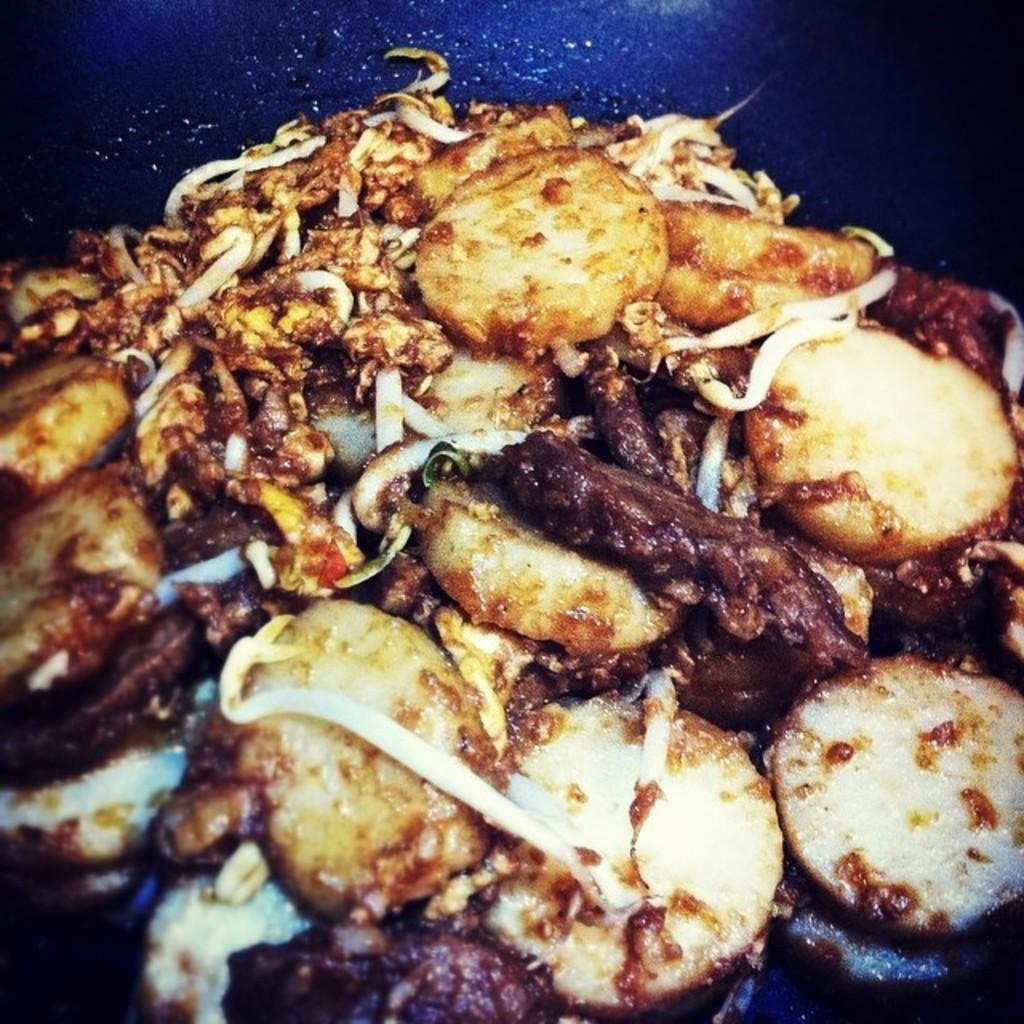What type of food is featured in the image? There is seafood in the image. In which direction is the vacation heading in the image? There is no vacation or direction present in the image; it only features seafood. 